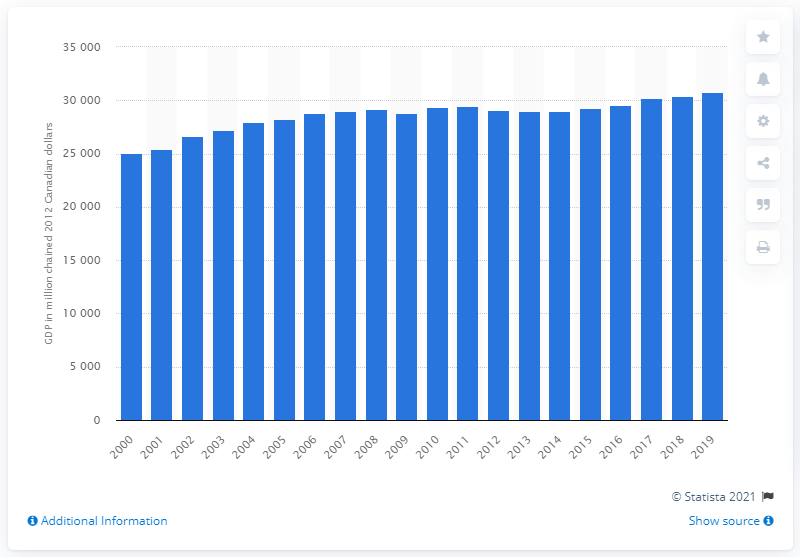List a handful of essential elements in this visual. In 2012, the gross domestic product (GDP) of New Brunswick was 307,454.4 dollars. 